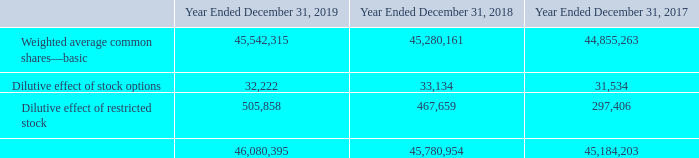1. Description of the business and summary of significant accounting policies: (Continued)
Shares of restricted stock are included in the computation of basic EPS as they vest and are included in diluted EPS, to the extent they are dilutive, determined using the treasury stock method.
The following details the determination of the diluted weighted average shares:
What are the respective number of basic weighted average common shares in 2018 and 2019? 45,280,161, 45,542,315. What are the respective number of basic weighted average common shares in 2017 and 2018? 44,855,263, 45,280,161. What are the respective number of dilutive effect of stock options in 2018 and 2019? 33,134, 32,222. What is the average number of basic weighted average common shares in 2018 and 2019? (45,542,315 + 45,280,161)/2
Answer: 45411238. What is the average number of basic weighted average common shares in 2017 and 2018? (44,855,263 + 45,280,161)/2 
Answer: 45067712. What is the average dilutive effect of stock options in 2018 and 2019? (33,134 + 32,222)/2 
Answer: 32678. 